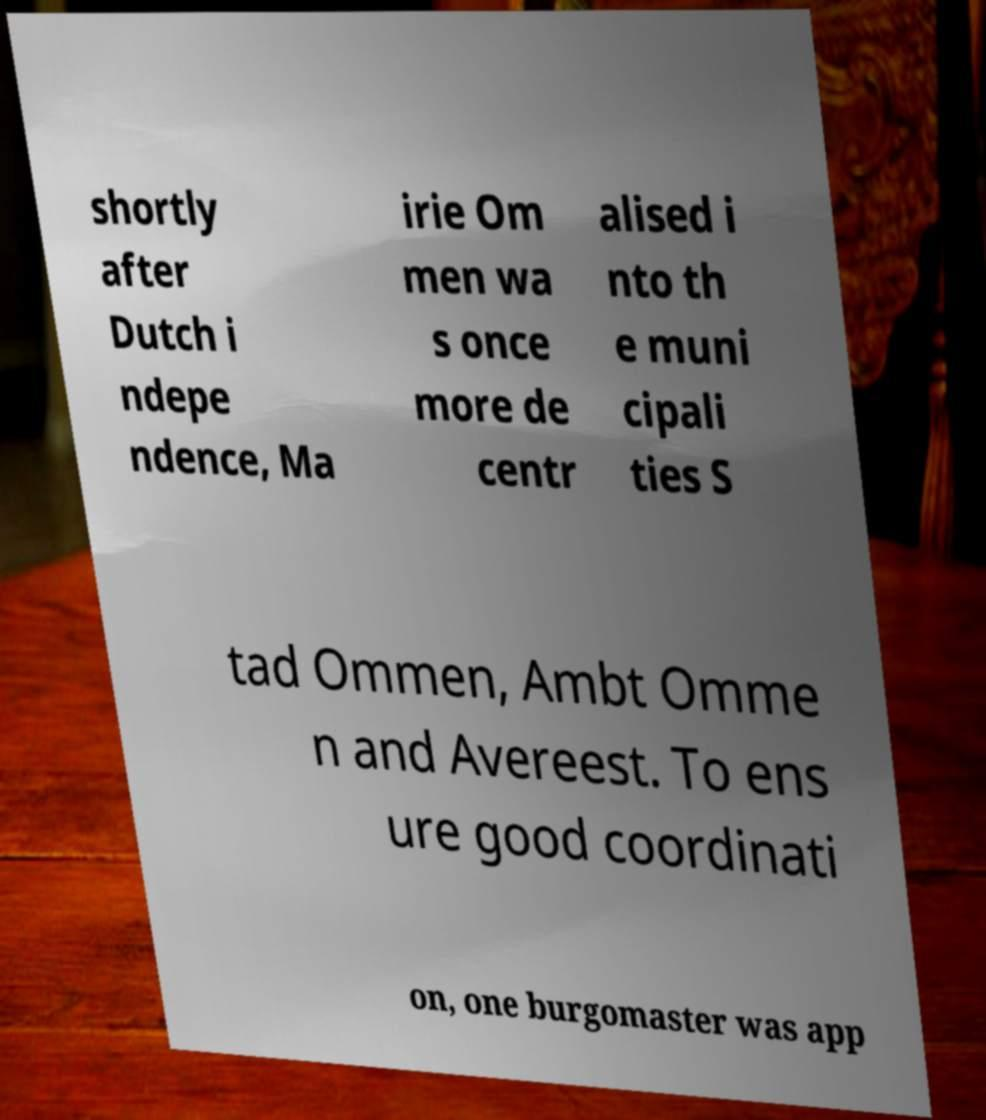I need the written content from this picture converted into text. Can you do that? shortly after Dutch i ndepe ndence, Ma irie Om men wa s once more de centr alised i nto th e muni cipali ties S tad Ommen, Ambt Omme n and Avereest. To ens ure good coordinati on, one burgomaster was app 